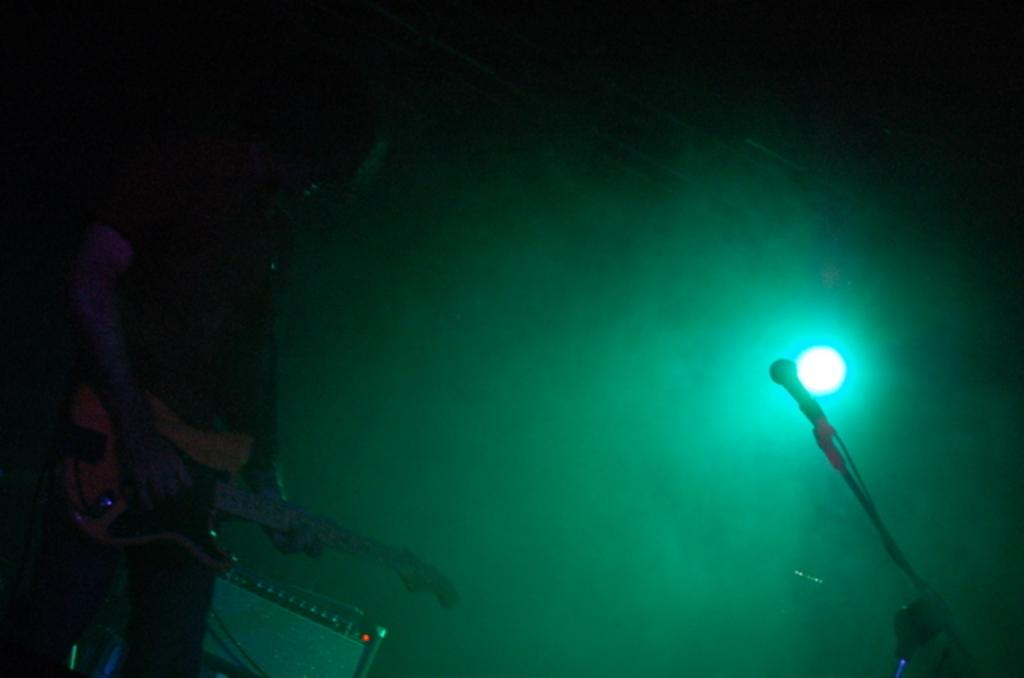What is the main subject of the image? There is a person in the image. What is the person doing in the image? The person is playing the guitar. Can you describe the lighting in the image? There is a green light focusing on the person. What object is in front of the person? There is a microphone (mic) in front of the person. What type of unit is being measured in the image? There is no unit being measured in the image; it features a person playing the guitar with a green light and a microphone. 